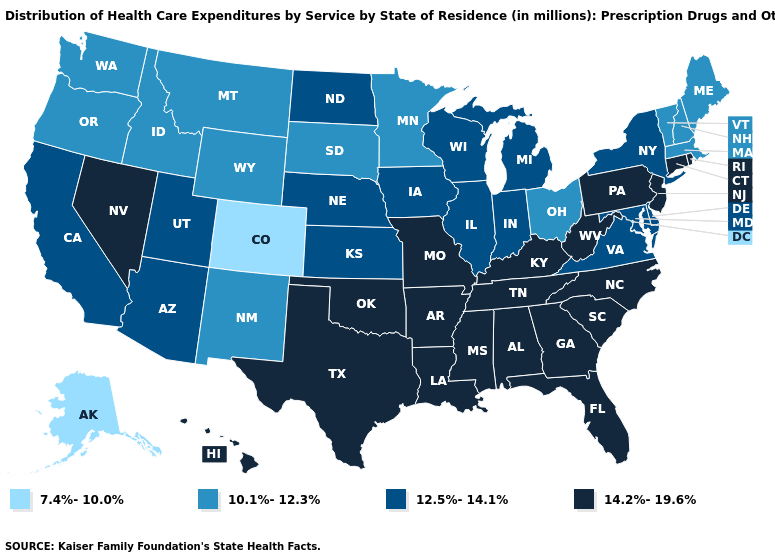Name the states that have a value in the range 14.2%-19.6%?
Write a very short answer. Alabama, Arkansas, Connecticut, Florida, Georgia, Hawaii, Kentucky, Louisiana, Mississippi, Missouri, Nevada, New Jersey, North Carolina, Oklahoma, Pennsylvania, Rhode Island, South Carolina, Tennessee, Texas, West Virginia. How many symbols are there in the legend?
Keep it brief. 4. How many symbols are there in the legend?
Short answer required. 4. Does the first symbol in the legend represent the smallest category?
Give a very brief answer. Yes. Does Hawaii have the highest value in the West?
Write a very short answer. Yes. Name the states that have a value in the range 14.2%-19.6%?
Concise answer only. Alabama, Arkansas, Connecticut, Florida, Georgia, Hawaii, Kentucky, Louisiana, Mississippi, Missouri, Nevada, New Jersey, North Carolina, Oklahoma, Pennsylvania, Rhode Island, South Carolina, Tennessee, Texas, West Virginia. Name the states that have a value in the range 10.1%-12.3%?
Write a very short answer. Idaho, Maine, Massachusetts, Minnesota, Montana, New Hampshire, New Mexico, Ohio, Oregon, South Dakota, Vermont, Washington, Wyoming. Name the states that have a value in the range 12.5%-14.1%?
Write a very short answer. Arizona, California, Delaware, Illinois, Indiana, Iowa, Kansas, Maryland, Michigan, Nebraska, New York, North Dakota, Utah, Virginia, Wisconsin. What is the value of New Hampshire?
Be succinct. 10.1%-12.3%. Does the map have missing data?
Keep it brief. No. Does the first symbol in the legend represent the smallest category?
Be succinct. Yes. Is the legend a continuous bar?
Quick response, please. No. Among the states that border Delaware , does New Jersey have the highest value?
Concise answer only. Yes. 